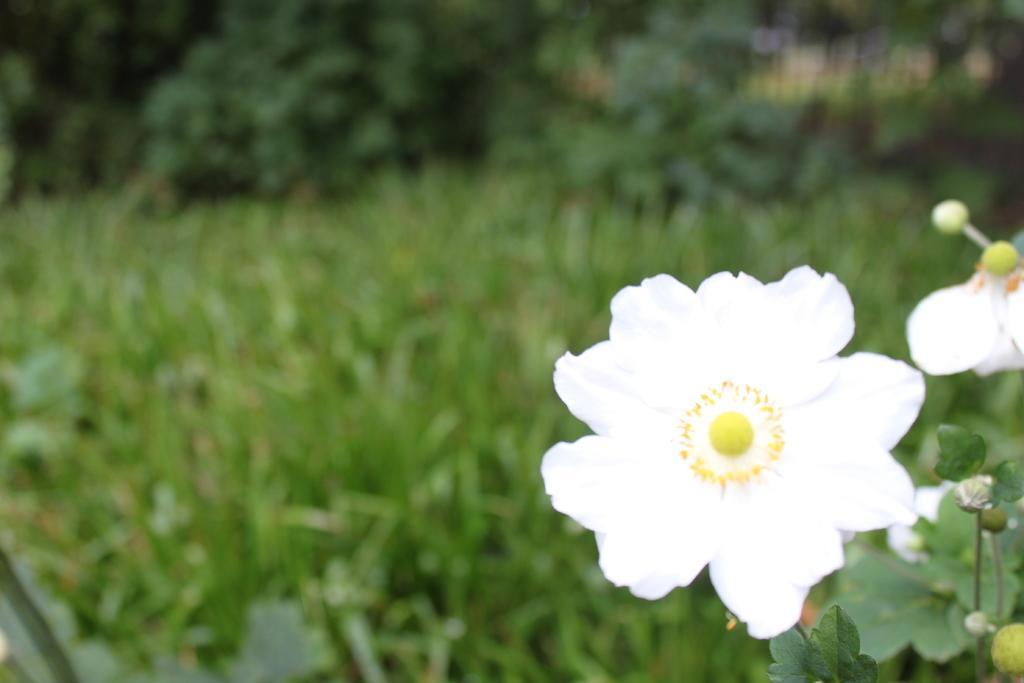Describe this image in one or two sentences. In the image we can see there is a white flower and the ground is covered with plants. Behind the image is little blurry. 